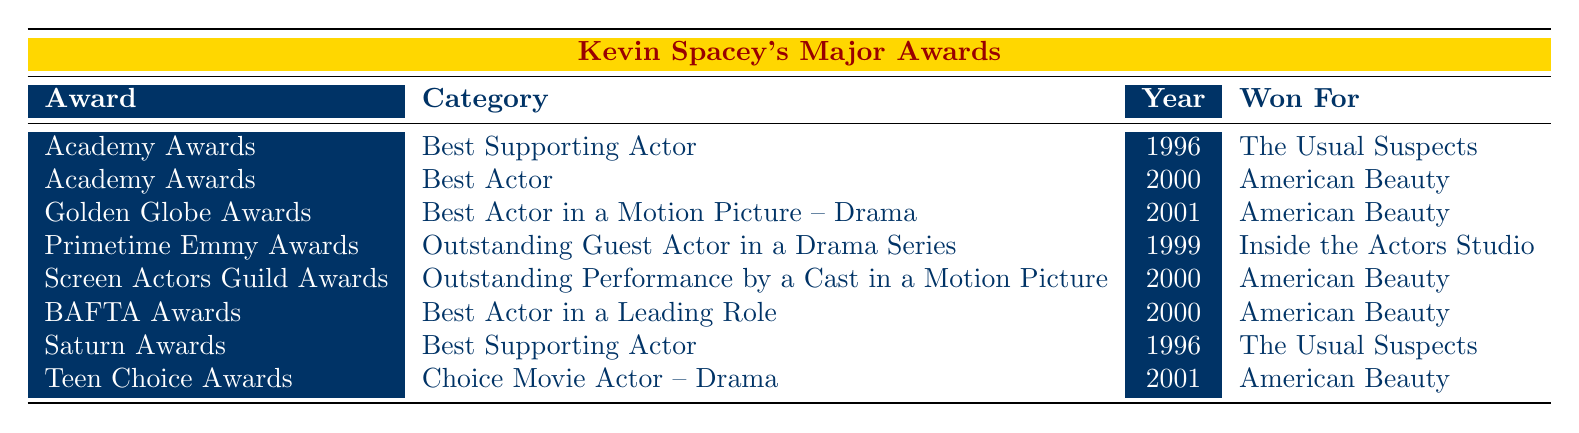What is the award Kevin Spacey won for "The Usual Suspects"? Kevin Spacey won the Academy Award for Best Supporting Actor for "The Usual Suspects" in 1996, as indicated in the first row of the table.
Answer: Academy Awards, Best Supporting Actor How many awards did Kevin Spacey win in the year 2000? In the year 2000, Kevin Spacey won three awards: the Academy Award for Best Actor, the Screen Actors Guild Award for Outstanding Performance by a Cast in a Motion Picture, and the BAFTA Award for Best Actor in a Leading Role, as seen in the relevant rows of the table.
Answer: 3 Did Kevin Spacey win an award for his performance in "Inside the Actors Studio"? Yes, Kevin Spacey won a Primetime Emmy Award for Outstanding Guest Actor in a Drama Series for his performance in "Inside the Actors Studio" in 1999, as shown in the appropriate row of the table.
Answer: Yes Which award was Kevin Spacey nominated for that year did he also win the Golden Globe Award for "American Beauty"? Kevin Spacey won the Golden Globe Award for Best Actor in a Motion Picture – Drama in 2001 for "American Beauty." There are no other awards listed for that specific year in the table, indicating he was recognized for this role.
Answer: Golden Globe Awards How many different categories did Kevin Spacey receive nominations for across all awards listed in the table? Looking at the table, Kevin Spacey received nominations in five distinct categories: Best Supporting Actor, Best Actor, Outstanding Guest Actor in a Drama Series, Outstanding Performance by a Cast in a Motion Picture, and Best Actor in a Leading Role. These categories represent the various forms of recognition from the different awards.
Answer: 5 How many awards did Kevin Spacey win for roles released before 2000? Kevin Spacey won three awards for roles released before 2000: the Academy Award for Best Supporting Actor for "The Usual Suspects" in 1996, the Saturn Award for Best Supporting Actor also in 1996, and the Primetime Emmy Award in 1999 for "Inside the Actors Studio."
Answer: 3 Was "American Beauty" the only film for which Kevin Spacey won more than one award? Yes, "American Beauty" is the only film for which Kevin Spacey won multiple awards: he won the Academy Award for Best Actor, the Golden Globe Award for Best Actor in a Motion Picture – Drama, the Screen Actors Guild Award for Outstanding Performance by a Cast in a Motion Picture, and the BAFTA Award for Best Actor in a Leading Role, all for the same film.
Answer: Yes Which award did Kevin Spacey win for a role in a film released in 1996? Kevin Spacey won both the Academy Award for Best Supporting Actor and the Saturn Award for Best Supporting Actor for his role in "The Usual Suspects," which was released in 1996. Both awards appear in the table with the corresponding details.
Answer: Academy Awards, Saturn Awards 